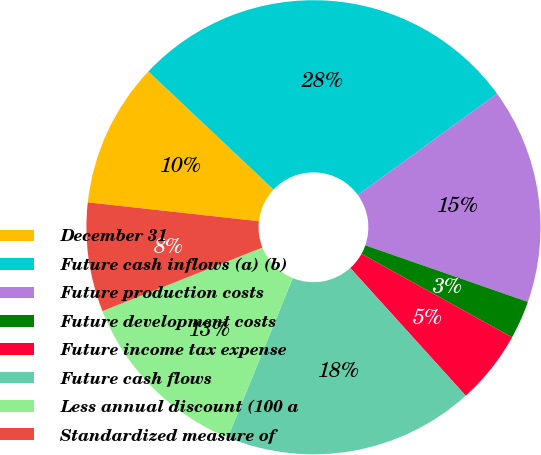Convert chart to OTSL. <chart><loc_0><loc_0><loc_500><loc_500><pie_chart><fcel>December 31<fcel>Future cash inflows (a) (b)<fcel>Future production costs<fcel>Future development costs<fcel>Future income tax expense<fcel>Future cash flows<fcel>Less annual discount (100 a<fcel>Standardized measure of<nl><fcel>10.29%<fcel>27.95%<fcel>15.34%<fcel>2.72%<fcel>5.25%<fcel>17.86%<fcel>12.82%<fcel>7.77%<nl></chart> 